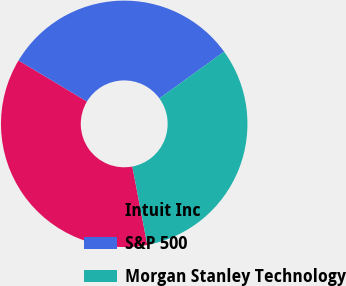Convert chart. <chart><loc_0><loc_0><loc_500><loc_500><pie_chart><fcel>Intuit Inc<fcel>S&P 500<fcel>Morgan Stanley Technology<nl><fcel>36.6%<fcel>31.44%<fcel>31.96%<nl></chart> 